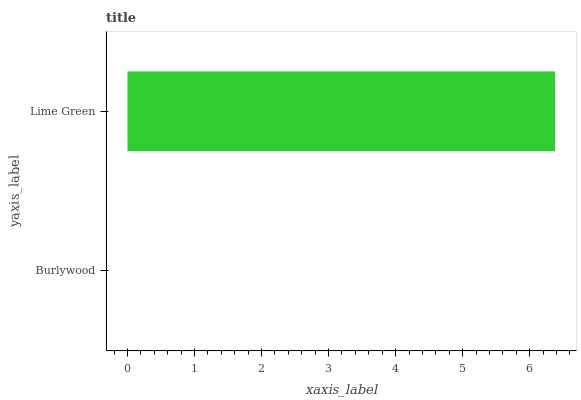Is Burlywood the minimum?
Answer yes or no. Yes. Is Lime Green the maximum?
Answer yes or no. Yes. Is Lime Green the minimum?
Answer yes or no. No. Is Lime Green greater than Burlywood?
Answer yes or no. Yes. Is Burlywood less than Lime Green?
Answer yes or no. Yes. Is Burlywood greater than Lime Green?
Answer yes or no. No. Is Lime Green less than Burlywood?
Answer yes or no. No. Is Lime Green the high median?
Answer yes or no. Yes. Is Burlywood the low median?
Answer yes or no. Yes. Is Burlywood the high median?
Answer yes or no. No. Is Lime Green the low median?
Answer yes or no. No. 